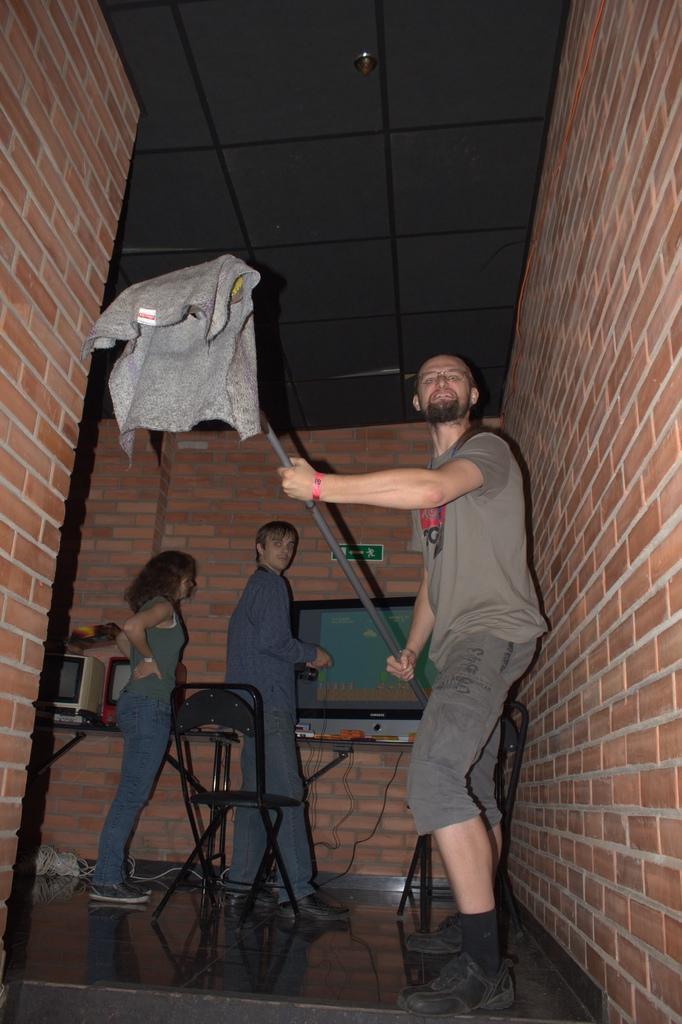In one or two sentences, can you explain what this image depicts? In this image there is a person holding some object. Behind him there are a few other people. There are chairs. There is a TV on the table. On the left side of the image there are computers on the table. In the background of the image there are brick walls. At the bottom of the image there is a floor. 